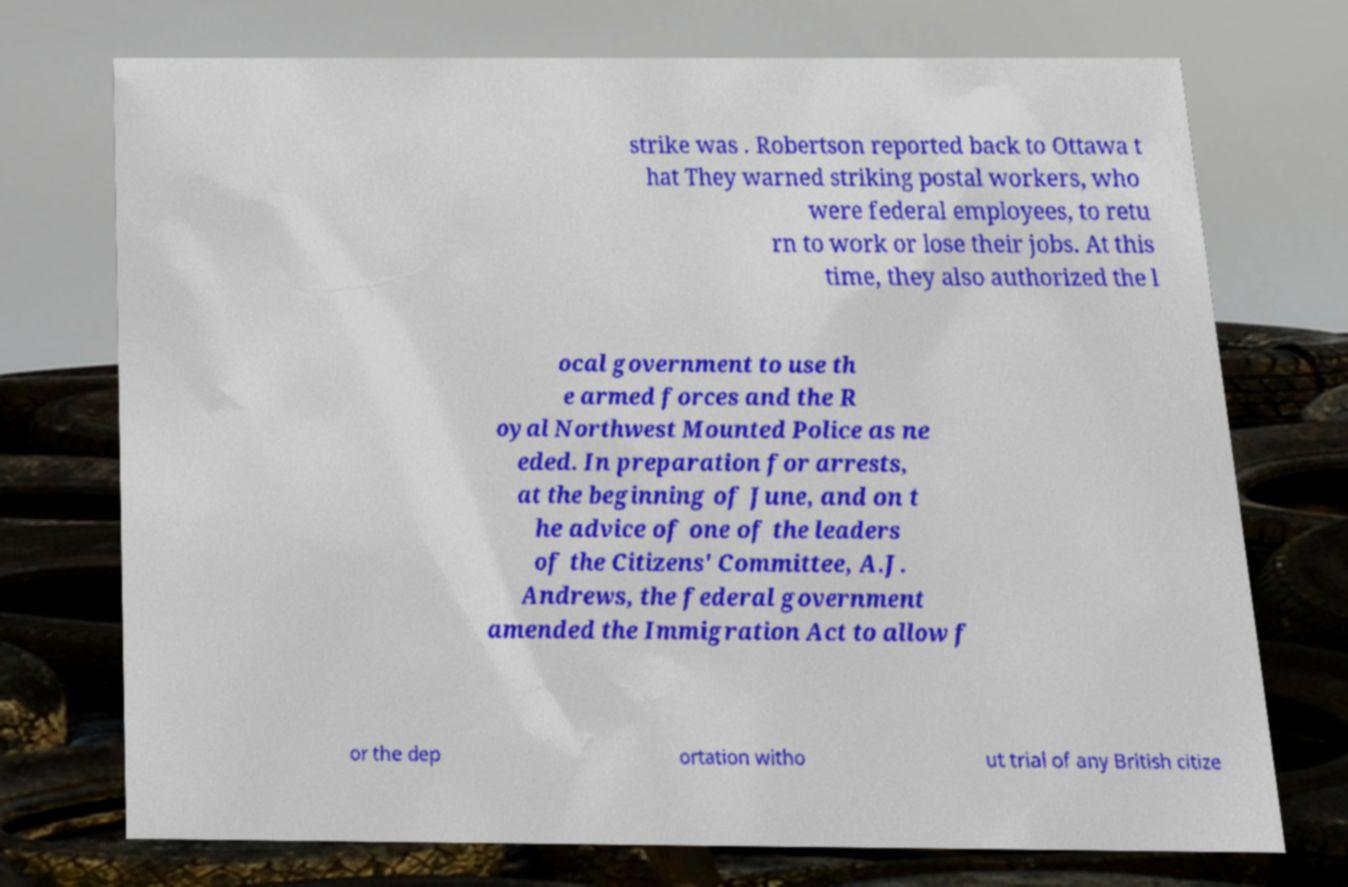I need the written content from this picture converted into text. Can you do that? strike was . Robertson reported back to Ottawa t hat They warned striking postal workers, who were federal employees, to retu rn to work or lose their jobs. At this time, they also authorized the l ocal government to use th e armed forces and the R oyal Northwest Mounted Police as ne eded. In preparation for arrests, at the beginning of June, and on t he advice of one of the leaders of the Citizens' Committee, A.J. Andrews, the federal government amended the Immigration Act to allow f or the dep ortation witho ut trial of any British citize 